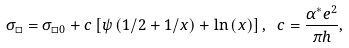Convert formula to latex. <formula><loc_0><loc_0><loc_500><loc_500>\sigma _ { \square } = \sigma _ { \square 0 } + c \left [ \psi \left ( 1 / 2 + 1 / x \right ) + \ln \left ( x \right ) \right ] , \text { } c = \frac { \alpha ^ { \ast } e ^ { 2 } } { \pi h } ,</formula> 